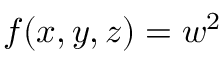Convert formula to latex. <formula><loc_0><loc_0><loc_500><loc_500>f ( x , y , z ) = w ^ { 2 }</formula> 